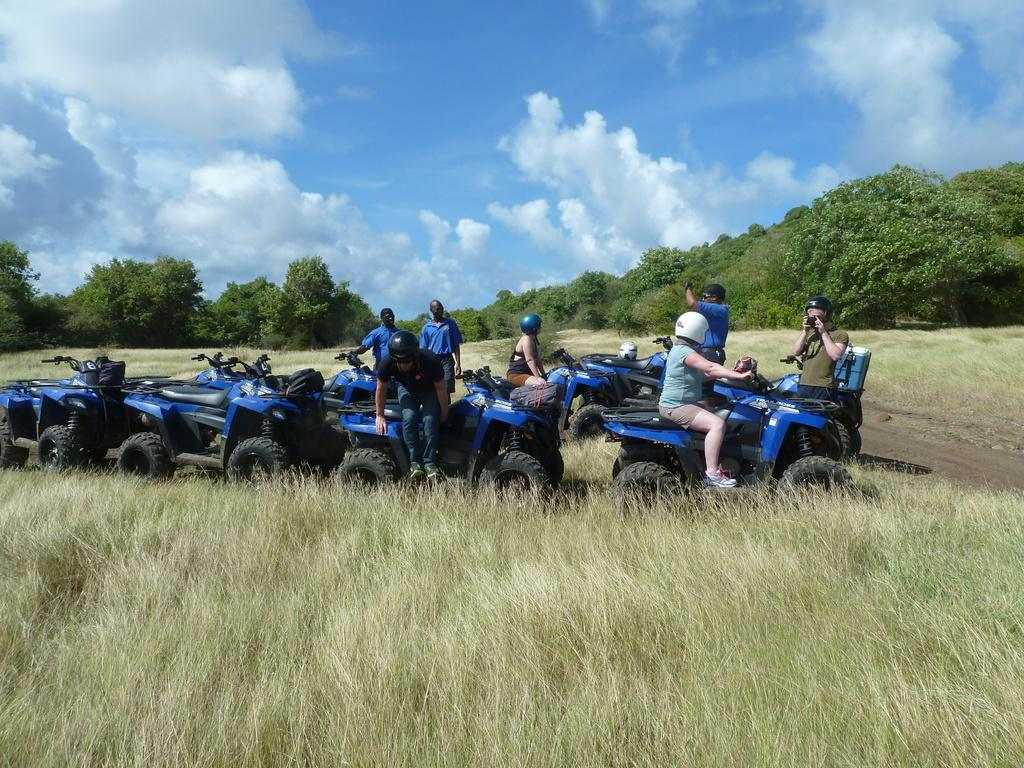What are the people in the image doing? The people in the image are sitting. Where are the people sitting? The people are sitting on the quad. What type of surface can be seen in the image? There is grass on the surface in the image. What can be seen in the background of the image? There are trees and the sky visible in the background of the image. How many tickets were sold for the event in the image? There is no event or ticket sales mentioned in the image; it simply shows people sitting on the grass. What is the profit generated from the activity in the image? There is no activity or profit mentioned in the image; it only shows people sitting on the grass. 